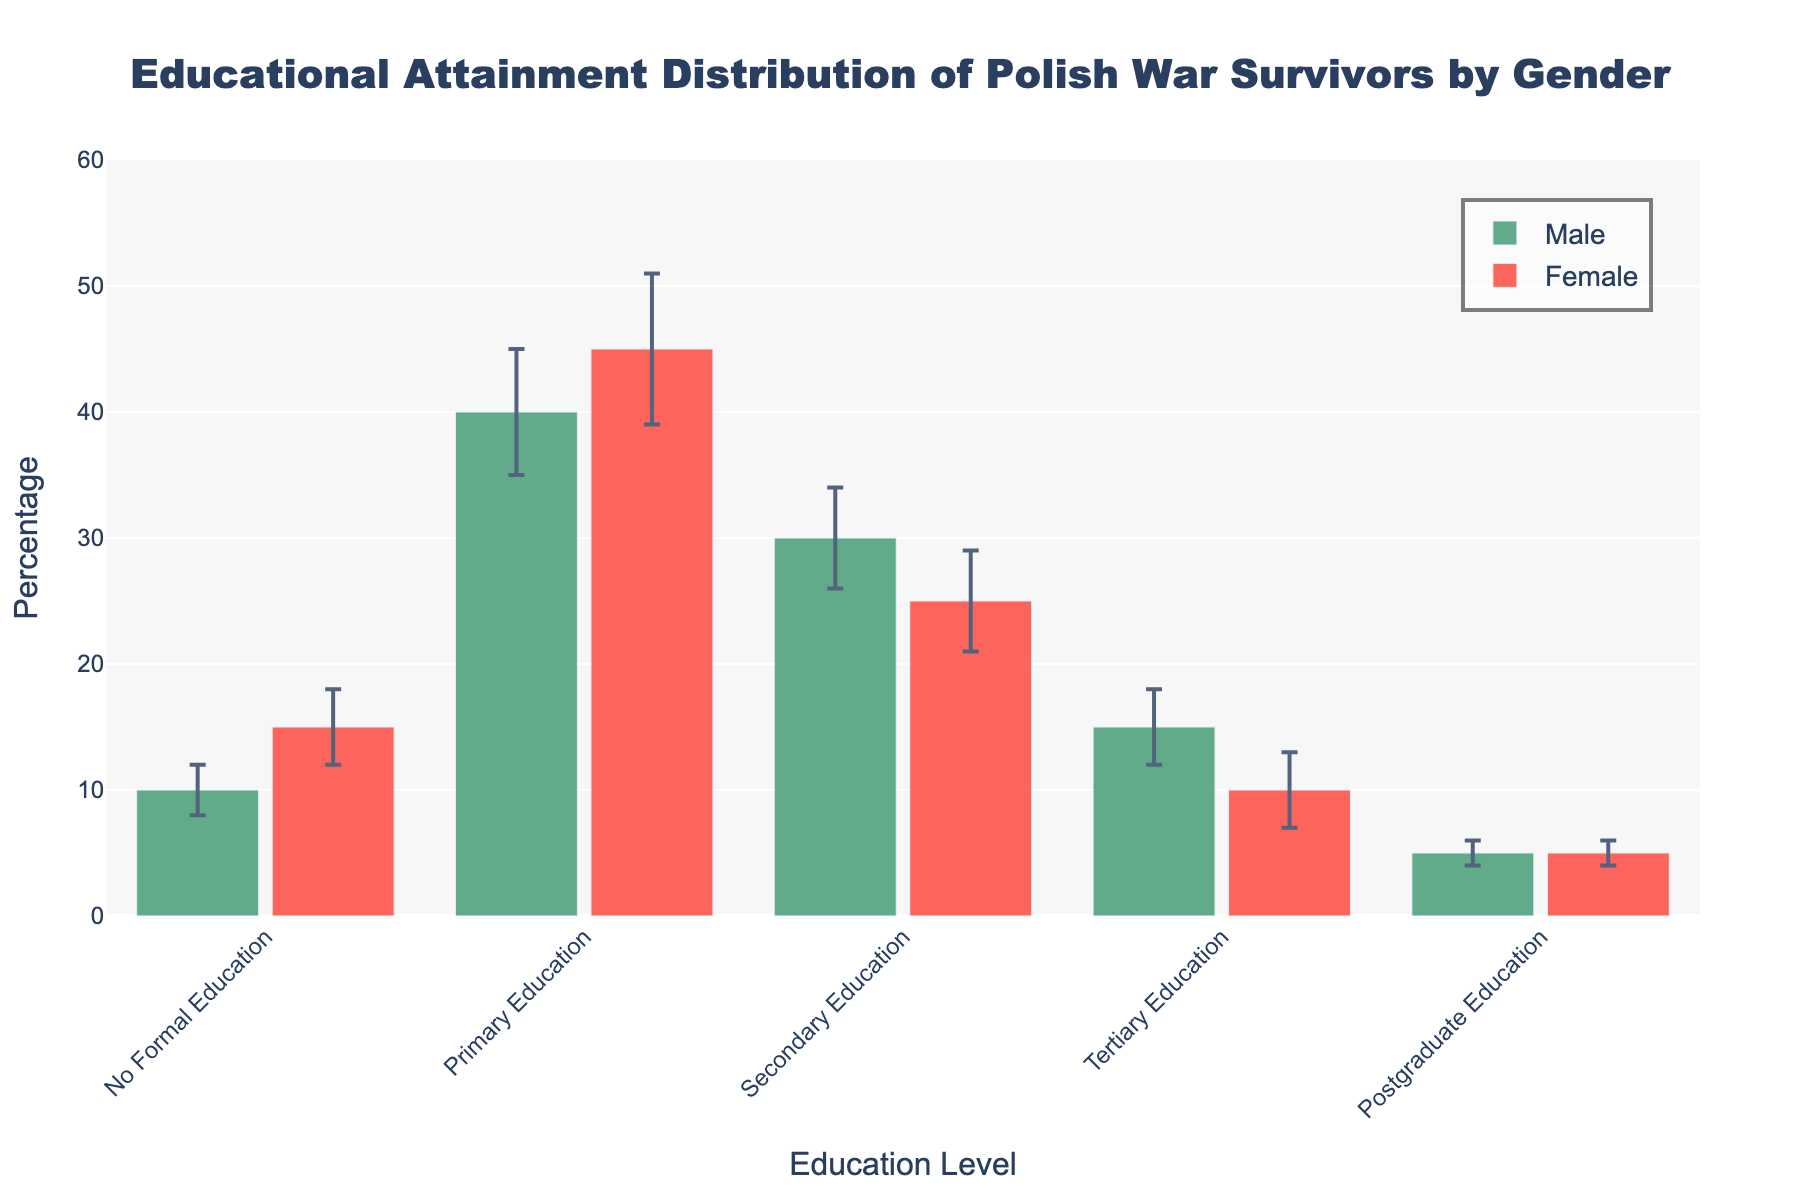What is the title of the figure? The title of the figure is displayed at the top of the chart, which summarizes the content or subject represented in the chart.
Answer: Educational Attainment Distribution of Polish War Survivors by Gender What is the percentage of female Polish war survivors with primary education? The percentage is indicated by the height of the female bar for Primary Education.
Answer: 45% Which education level has the largest percentage of male Polish war survivors? By comparing the heights of the bars representing males across all education levels, the highest bar signifies the largest percentage.
Answer: Primary Education What is the difference in the percentage of male and female Polish war survivors with secondary education? The percentages for males and females in Secondary Education are given, so subtract the smaller from the larger value. 30% (male) - 25% (female) = 5%.
Answer: 5% Which gender has a higher percentage of Polish war survivors with tertiary education? By comparing the heights of the bars for both males and females in Tertiary Education, the taller bar represents the higher percentage.
Answer: Male For females, which education levels have error bars larger than 4%? Look at the error bars for each education level for females and identify those with values greater than 4%. Only "Primary Education" meets this criterion.
Answer: Primary Education What is the average percentage of Polish war survivors with no formal education for both genders? Calculate the average by adding the percentages for both males and females in No Formal Education and dividing by 2. (10% + 15%) / 2 = 12.5%
Answer: 12.5% Comparing males, which education level has the smallest percentage of Polish war survivors? By identifying the shortest bar among the male data points, the smallest percentage is indicated.
Answer: Postgraduate Education How does the error margin for male Polish war survivors with tertiary education compare to the error margin for females with the same education level? Compare the error values directly for males and females in Tertiary Education. Both have an error of 3%.
Answer: The same Which education level has the greatest difference in percentage between males and females? Calculate the absolute differences in percentage for each education level and find the largest one: No Formal (5%), Primary (5%), Secondary (5%), Tertiary (5%), Postgraduate (0%).
Answer: No Formal, Primary, Secondary, Tertiary 